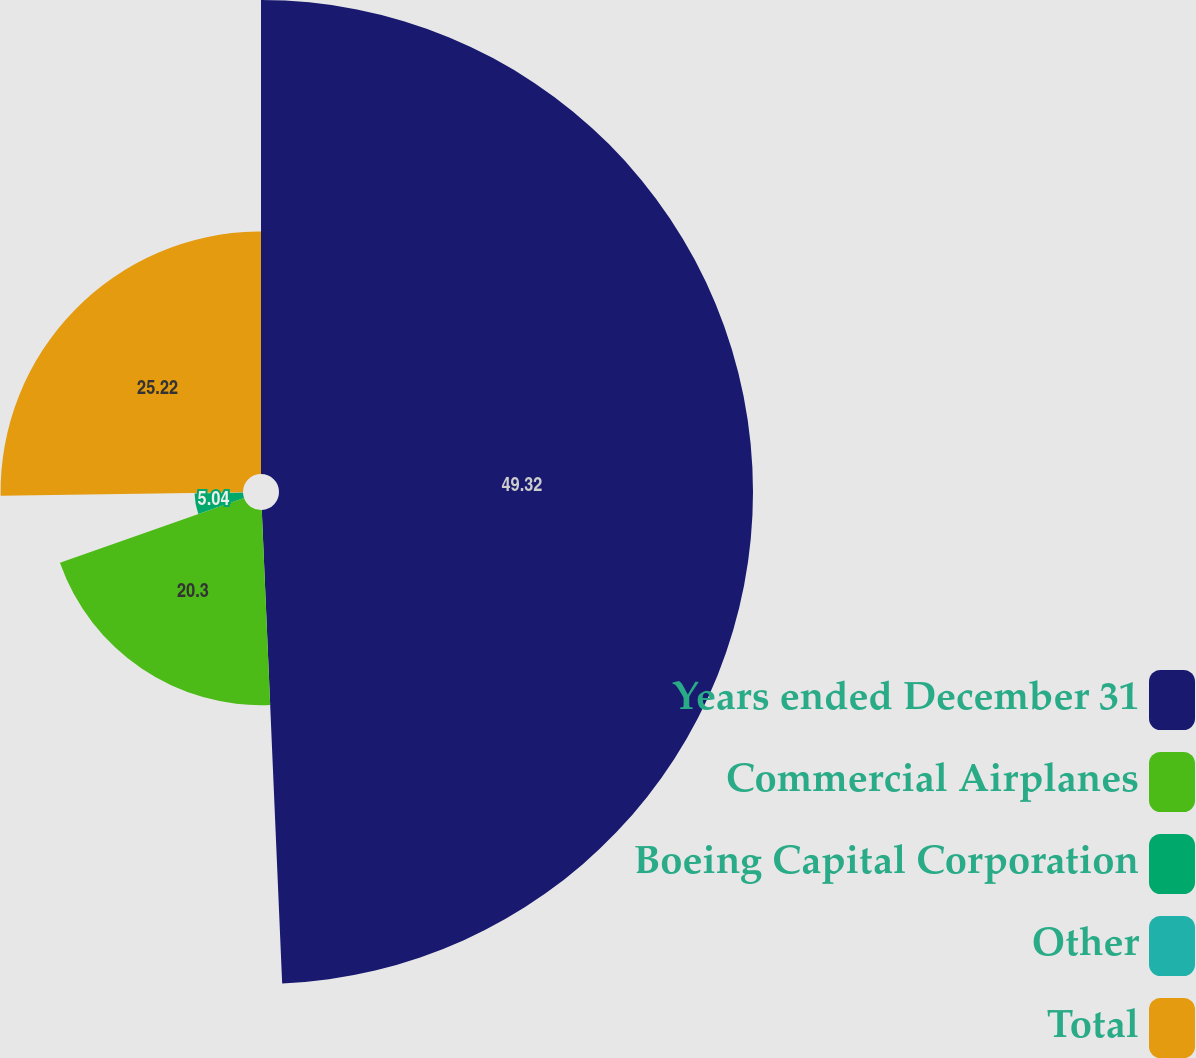Convert chart. <chart><loc_0><loc_0><loc_500><loc_500><pie_chart><fcel>Years ended December 31<fcel>Commercial Airplanes<fcel>Boeing Capital Corporation<fcel>Other<fcel>Total<nl><fcel>49.31%<fcel>20.3%<fcel>5.04%<fcel>0.12%<fcel>25.22%<nl></chart> 